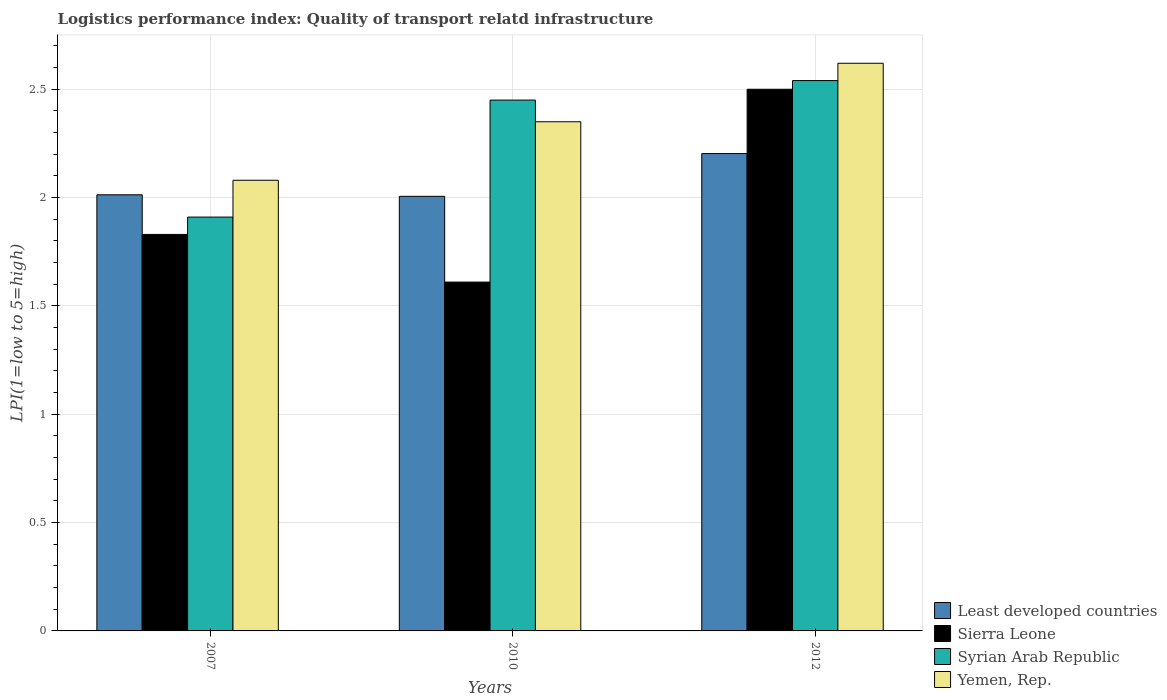How many different coloured bars are there?
Make the answer very short. 4. How many groups of bars are there?
Offer a terse response. 3. Are the number of bars per tick equal to the number of legend labels?
Offer a very short reply. Yes. Are the number of bars on each tick of the X-axis equal?
Your answer should be very brief. Yes. What is the label of the 1st group of bars from the left?
Provide a succinct answer. 2007. What is the logistics performance index in Least developed countries in 2012?
Offer a terse response. 2.2. Across all years, what is the minimum logistics performance index in Sierra Leone?
Keep it short and to the point. 1.61. In which year was the logistics performance index in Sierra Leone maximum?
Make the answer very short. 2012. What is the total logistics performance index in Least developed countries in the graph?
Your answer should be very brief. 6.22. What is the difference between the logistics performance index in Yemen, Rep. in 2010 and that in 2012?
Give a very brief answer. -0.27. What is the difference between the logistics performance index in Least developed countries in 2010 and the logistics performance index in Syrian Arab Republic in 2012?
Your response must be concise. -0.53. What is the average logistics performance index in Yemen, Rep. per year?
Keep it short and to the point. 2.35. In the year 2012, what is the difference between the logistics performance index in Least developed countries and logistics performance index in Syrian Arab Republic?
Provide a short and direct response. -0.34. In how many years, is the logistics performance index in Least developed countries greater than 2?
Offer a very short reply. 3. What is the ratio of the logistics performance index in Sierra Leone in 2010 to that in 2012?
Provide a succinct answer. 0.64. Is the difference between the logistics performance index in Least developed countries in 2010 and 2012 greater than the difference between the logistics performance index in Syrian Arab Republic in 2010 and 2012?
Give a very brief answer. No. What is the difference between the highest and the second highest logistics performance index in Sierra Leone?
Ensure brevity in your answer.  0.67. What is the difference between the highest and the lowest logistics performance index in Sierra Leone?
Offer a terse response. 0.89. Is the sum of the logistics performance index in Yemen, Rep. in 2010 and 2012 greater than the maximum logistics performance index in Syrian Arab Republic across all years?
Make the answer very short. Yes. Is it the case that in every year, the sum of the logistics performance index in Least developed countries and logistics performance index in Syrian Arab Republic is greater than the sum of logistics performance index in Yemen, Rep. and logistics performance index in Sierra Leone?
Offer a terse response. No. What does the 1st bar from the left in 2012 represents?
Give a very brief answer. Least developed countries. What does the 4th bar from the right in 2012 represents?
Provide a short and direct response. Least developed countries. How many years are there in the graph?
Provide a succinct answer. 3. Are the values on the major ticks of Y-axis written in scientific E-notation?
Provide a short and direct response. No. How are the legend labels stacked?
Make the answer very short. Vertical. What is the title of the graph?
Provide a succinct answer. Logistics performance index: Quality of transport relatd infrastructure. Does "Maldives" appear as one of the legend labels in the graph?
Your answer should be very brief. No. What is the label or title of the Y-axis?
Keep it short and to the point. LPI(1=low to 5=high). What is the LPI(1=low to 5=high) of Least developed countries in 2007?
Your answer should be very brief. 2.01. What is the LPI(1=low to 5=high) of Sierra Leone in 2007?
Provide a succinct answer. 1.83. What is the LPI(1=low to 5=high) in Syrian Arab Republic in 2007?
Ensure brevity in your answer.  1.91. What is the LPI(1=low to 5=high) of Yemen, Rep. in 2007?
Give a very brief answer. 2.08. What is the LPI(1=low to 5=high) of Least developed countries in 2010?
Offer a terse response. 2.01. What is the LPI(1=low to 5=high) of Sierra Leone in 2010?
Offer a very short reply. 1.61. What is the LPI(1=low to 5=high) of Syrian Arab Republic in 2010?
Provide a succinct answer. 2.45. What is the LPI(1=low to 5=high) of Yemen, Rep. in 2010?
Make the answer very short. 2.35. What is the LPI(1=low to 5=high) in Least developed countries in 2012?
Your response must be concise. 2.2. What is the LPI(1=low to 5=high) in Syrian Arab Republic in 2012?
Your response must be concise. 2.54. What is the LPI(1=low to 5=high) of Yemen, Rep. in 2012?
Offer a very short reply. 2.62. Across all years, what is the maximum LPI(1=low to 5=high) in Least developed countries?
Give a very brief answer. 2.2. Across all years, what is the maximum LPI(1=low to 5=high) in Sierra Leone?
Keep it short and to the point. 2.5. Across all years, what is the maximum LPI(1=low to 5=high) in Syrian Arab Republic?
Your answer should be very brief. 2.54. Across all years, what is the maximum LPI(1=low to 5=high) of Yemen, Rep.?
Your answer should be compact. 2.62. Across all years, what is the minimum LPI(1=low to 5=high) in Least developed countries?
Offer a very short reply. 2.01. Across all years, what is the minimum LPI(1=low to 5=high) of Sierra Leone?
Give a very brief answer. 1.61. Across all years, what is the minimum LPI(1=low to 5=high) of Syrian Arab Republic?
Your answer should be compact. 1.91. Across all years, what is the minimum LPI(1=low to 5=high) in Yemen, Rep.?
Your answer should be compact. 2.08. What is the total LPI(1=low to 5=high) in Least developed countries in the graph?
Offer a very short reply. 6.22. What is the total LPI(1=low to 5=high) of Sierra Leone in the graph?
Give a very brief answer. 5.94. What is the total LPI(1=low to 5=high) of Yemen, Rep. in the graph?
Provide a succinct answer. 7.05. What is the difference between the LPI(1=low to 5=high) in Least developed countries in 2007 and that in 2010?
Make the answer very short. 0.01. What is the difference between the LPI(1=low to 5=high) in Sierra Leone in 2007 and that in 2010?
Offer a very short reply. 0.22. What is the difference between the LPI(1=low to 5=high) of Syrian Arab Republic in 2007 and that in 2010?
Provide a succinct answer. -0.54. What is the difference between the LPI(1=low to 5=high) of Yemen, Rep. in 2007 and that in 2010?
Offer a very short reply. -0.27. What is the difference between the LPI(1=low to 5=high) of Least developed countries in 2007 and that in 2012?
Make the answer very short. -0.19. What is the difference between the LPI(1=low to 5=high) in Sierra Leone in 2007 and that in 2012?
Ensure brevity in your answer.  -0.67. What is the difference between the LPI(1=low to 5=high) in Syrian Arab Republic in 2007 and that in 2012?
Give a very brief answer. -0.63. What is the difference between the LPI(1=low to 5=high) in Yemen, Rep. in 2007 and that in 2012?
Your answer should be very brief. -0.54. What is the difference between the LPI(1=low to 5=high) of Least developed countries in 2010 and that in 2012?
Keep it short and to the point. -0.2. What is the difference between the LPI(1=low to 5=high) of Sierra Leone in 2010 and that in 2012?
Your answer should be very brief. -0.89. What is the difference between the LPI(1=low to 5=high) in Syrian Arab Republic in 2010 and that in 2012?
Your answer should be very brief. -0.09. What is the difference between the LPI(1=low to 5=high) of Yemen, Rep. in 2010 and that in 2012?
Your response must be concise. -0.27. What is the difference between the LPI(1=low to 5=high) in Least developed countries in 2007 and the LPI(1=low to 5=high) in Sierra Leone in 2010?
Keep it short and to the point. 0.4. What is the difference between the LPI(1=low to 5=high) of Least developed countries in 2007 and the LPI(1=low to 5=high) of Syrian Arab Republic in 2010?
Make the answer very short. -0.44. What is the difference between the LPI(1=low to 5=high) in Least developed countries in 2007 and the LPI(1=low to 5=high) in Yemen, Rep. in 2010?
Make the answer very short. -0.34. What is the difference between the LPI(1=low to 5=high) of Sierra Leone in 2007 and the LPI(1=low to 5=high) of Syrian Arab Republic in 2010?
Provide a succinct answer. -0.62. What is the difference between the LPI(1=low to 5=high) in Sierra Leone in 2007 and the LPI(1=low to 5=high) in Yemen, Rep. in 2010?
Offer a very short reply. -0.52. What is the difference between the LPI(1=low to 5=high) of Syrian Arab Republic in 2007 and the LPI(1=low to 5=high) of Yemen, Rep. in 2010?
Provide a short and direct response. -0.44. What is the difference between the LPI(1=low to 5=high) in Least developed countries in 2007 and the LPI(1=low to 5=high) in Sierra Leone in 2012?
Your answer should be very brief. -0.49. What is the difference between the LPI(1=low to 5=high) in Least developed countries in 2007 and the LPI(1=low to 5=high) in Syrian Arab Republic in 2012?
Provide a short and direct response. -0.53. What is the difference between the LPI(1=low to 5=high) of Least developed countries in 2007 and the LPI(1=low to 5=high) of Yemen, Rep. in 2012?
Provide a short and direct response. -0.61. What is the difference between the LPI(1=low to 5=high) of Sierra Leone in 2007 and the LPI(1=low to 5=high) of Syrian Arab Republic in 2012?
Your answer should be compact. -0.71. What is the difference between the LPI(1=low to 5=high) in Sierra Leone in 2007 and the LPI(1=low to 5=high) in Yemen, Rep. in 2012?
Your response must be concise. -0.79. What is the difference between the LPI(1=low to 5=high) in Syrian Arab Republic in 2007 and the LPI(1=low to 5=high) in Yemen, Rep. in 2012?
Your answer should be compact. -0.71. What is the difference between the LPI(1=low to 5=high) in Least developed countries in 2010 and the LPI(1=low to 5=high) in Sierra Leone in 2012?
Ensure brevity in your answer.  -0.49. What is the difference between the LPI(1=low to 5=high) in Least developed countries in 2010 and the LPI(1=low to 5=high) in Syrian Arab Republic in 2012?
Make the answer very short. -0.53. What is the difference between the LPI(1=low to 5=high) of Least developed countries in 2010 and the LPI(1=low to 5=high) of Yemen, Rep. in 2012?
Provide a short and direct response. -0.61. What is the difference between the LPI(1=low to 5=high) of Sierra Leone in 2010 and the LPI(1=low to 5=high) of Syrian Arab Republic in 2012?
Your answer should be very brief. -0.93. What is the difference between the LPI(1=low to 5=high) in Sierra Leone in 2010 and the LPI(1=low to 5=high) in Yemen, Rep. in 2012?
Offer a very short reply. -1.01. What is the difference between the LPI(1=low to 5=high) of Syrian Arab Republic in 2010 and the LPI(1=low to 5=high) of Yemen, Rep. in 2012?
Your answer should be very brief. -0.17. What is the average LPI(1=low to 5=high) of Least developed countries per year?
Your answer should be compact. 2.07. What is the average LPI(1=low to 5=high) of Sierra Leone per year?
Make the answer very short. 1.98. What is the average LPI(1=low to 5=high) of Yemen, Rep. per year?
Offer a terse response. 2.35. In the year 2007, what is the difference between the LPI(1=low to 5=high) of Least developed countries and LPI(1=low to 5=high) of Sierra Leone?
Keep it short and to the point. 0.18. In the year 2007, what is the difference between the LPI(1=low to 5=high) of Least developed countries and LPI(1=low to 5=high) of Syrian Arab Republic?
Make the answer very short. 0.1. In the year 2007, what is the difference between the LPI(1=low to 5=high) of Least developed countries and LPI(1=low to 5=high) of Yemen, Rep.?
Give a very brief answer. -0.07. In the year 2007, what is the difference between the LPI(1=low to 5=high) in Sierra Leone and LPI(1=low to 5=high) in Syrian Arab Republic?
Give a very brief answer. -0.08. In the year 2007, what is the difference between the LPI(1=low to 5=high) of Sierra Leone and LPI(1=low to 5=high) of Yemen, Rep.?
Provide a short and direct response. -0.25. In the year 2007, what is the difference between the LPI(1=low to 5=high) in Syrian Arab Republic and LPI(1=low to 5=high) in Yemen, Rep.?
Offer a terse response. -0.17. In the year 2010, what is the difference between the LPI(1=low to 5=high) in Least developed countries and LPI(1=low to 5=high) in Sierra Leone?
Provide a succinct answer. 0.4. In the year 2010, what is the difference between the LPI(1=low to 5=high) of Least developed countries and LPI(1=low to 5=high) of Syrian Arab Republic?
Your answer should be very brief. -0.44. In the year 2010, what is the difference between the LPI(1=low to 5=high) of Least developed countries and LPI(1=low to 5=high) of Yemen, Rep.?
Ensure brevity in your answer.  -0.34. In the year 2010, what is the difference between the LPI(1=low to 5=high) in Sierra Leone and LPI(1=low to 5=high) in Syrian Arab Republic?
Your answer should be very brief. -0.84. In the year 2010, what is the difference between the LPI(1=low to 5=high) in Sierra Leone and LPI(1=low to 5=high) in Yemen, Rep.?
Your answer should be compact. -0.74. In the year 2012, what is the difference between the LPI(1=low to 5=high) in Least developed countries and LPI(1=low to 5=high) in Sierra Leone?
Provide a short and direct response. -0.3. In the year 2012, what is the difference between the LPI(1=low to 5=high) in Least developed countries and LPI(1=low to 5=high) in Syrian Arab Republic?
Make the answer very short. -0.34. In the year 2012, what is the difference between the LPI(1=low to 5=high) of Least developed countries and LPI(1=low to 5=high) of Yemen, Rep.?
Offer a terse response. -0.42. In the year 2012, what is the difference between the LPI(1=low to 5=high) in Sierra Leone and LPI(1=low to 5=high) in Syrian Arab Republic?
Give a very brief answer. -0.04. In the year 2012, what is the difference between the LPI(1=low to 5=high) of Sierra Leone and LPI(1=low to 5=high) of Yemen, Rep.?
Your response must be concise. -0.12. In the year 2012, what is the difference between the LPI(1=low to 5=high) in Syrian Arab Republic and LPI(1=low to 5=high) in Yemen, Rep.?
Keep it short and to the point. -0.08. What is the ratio of the LPI(1=low to 5=high) of Sierra Leone in 2007 to that in 2010?
Keep it short and to the point. 1.14. What is the ratio of the LPI(1=low to 5=high) of Syrian Arab Republic in 2007 to that in 2010?
Ensure brevity in your answer.  0.78. What is the ratio of the LPI(1=low to 5=high) of Yemen, Rep. in 2007 to that in 2010?
Offer a terse response. 0.89. What is the ratio of the LPI(1=low to 5=high) of Least developed countries in 2007 to that in 2012?
Offer a very short reply. 0.91. What is the ratio of the LPI(1=low to 5=high) in Sierra Leone in 2007 to that in 2012?
Give a very brief answer. 0.73. What is the ratio of the LPI(1=low to 5=high) of Syrian Arab Republic in 2007 to that in 2012?
Your answer should be compact. 0.75. What is the ratio of the LPI(1=low to 5=high) of Yemen, Rep. in 2007 to that in 2012?
Keep it short and to the point. 0.79. What is the ratio of the LPI(1=low to 5=high) of Least developed countries in 2010 to that in 2012?
Ensure brevity in your answer.  0.91. What is the ratio of the LPI(1=low to 5=high) in Sierra Leone in 2010 to that in 2012?
Offer a very short reply. 0.64. What is the ratio of the LPI(1=low to 5=high) in Syrian Arab Republic in 2010 to that in 2012?
Your answer should be compact. 0.96. What is the ratio of the LPI(1=low to 5=high) of Yemen, Rep. in 2010 to that in 2012?
Provide a succinct answer. 0.9. What is the difference between the highest and the second highest LPI(1=low to 5=high) of Least developed countries?
Offer a very short reply. 0.19. What is the difference between the highest and the second highest LPI(1=low to 5=high) in Sierra Leone?
Keep it short and to the point. 0.67. What is the difference between the highest and the second highest LPI(1=low to 5=high) in Syrian Arab Republic?
Give a very brief answer. 0.09. What is the difference between the highest and the second highest LPI(1=low to 5=high) in Yemen, Rep.?
Offer a very short reply. 0.27. What is the difference between the highest and the lowest LPI(1=low to 5=high) of Least developed countries?
Make the answer very short. 0.2. What is the difference between the highest and the lowest LPI(1=low to 5=high) in Sierra Leone?
Keep it short and to the point. 0.89. What is the difference between the highest and the lowest LPI(1=low to 5=high) of Syrian Arab Republic?
Offer a terse response. 0.63. What is the difference between the highest and the lowest LPI(1=low to 5=high) of Yemen, Rep.?
Your answer should be very brief. 0.54. 